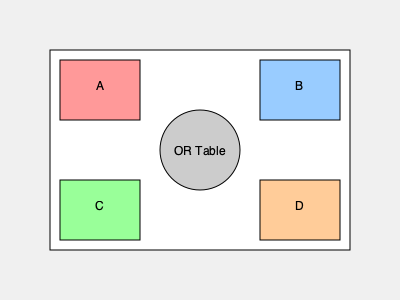Given the operating room layout shown, which arrangement of medical equipment (A, B, C, D) would minimize the average distance traveled by surgical staff during procedures, assuming equal importance for all equipment? Consider that the OR table is fixed in the center. To optimize the layout and minimize the average distance traveled, we need to consider the following steps:

1. Identify the central point: The OR table is fixed in the center, serving as the primary reference point.

2. Calculate distances: We need to determine the distance from the OR table to each equipment location (A, B, C, D).

3. Analyze movement patterns: Assume that staff need to access all equipment equally during procedures.

4. Optimize placement:
   a) Equipment used most frequently should be closest to the OR table.
   b) Paired equipment (if any) should be on opposite sides for balance.

5. Consider the layout:
   - A and B are equidistant from the OR table, forming one pair.
   - C and D are equidistant from the OR table, forming another pair.
   - A and C are on the same side, as are B and D.

6. Optimal arrangement:
   - Place the two most frequently used pieces of equipment in positions A and B.
   - Place the next two most frequently used in C and D.

This arrangement minimizes the average distance traveled because:
   - It balances the equipment around the OR table.
   - It ensures that at least one piece of equipment is always close, regardless of where the surgeon is standing.
   - It reduces the need for staff to cross the room frequently.

From a financial perspective, this optimal arrangement can lead to:
   - Reduced procedure times, increasing OR efficiency and throughput.
   - Decreased staff fatigue, potentially reducing errors and improving outcomes.
   - More efficient use of space, possibly allowing for additional equipment without compromising workflow.

These factors contribute to cost savings and potentially increased revenue, justifying the renovation project from a financial standpoint.
Answer: A-B, C-D pairing 